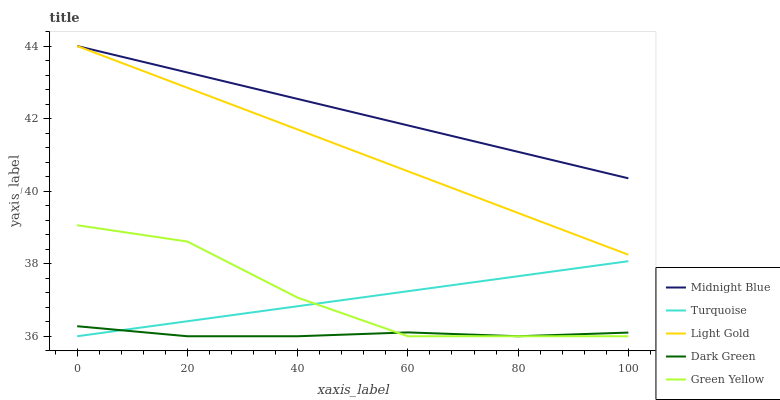Does Green Yellow have the minimum area under the curve?
Answer yes or no. No. Does Green Yellow have the maximum area under the curve?
Answer yes or no. No. Is Green Yellow the smoothest?
Answer yes or no. No. Is Light Gold the roughest?
Answer yes or no. No. Does Light Gold have the lowest value?
Answer yes or no. No. Does Green Yellow have the highest value?
Answer yes or no. No. Is Green Yellow less than Light Gold?
Answer yes or no. Yes. Is Midnight Blue greater than Dark Green?
Answer yes or no. Yes. Does Green Yellow intersect Light Gold?
Answer yes or no. No. 